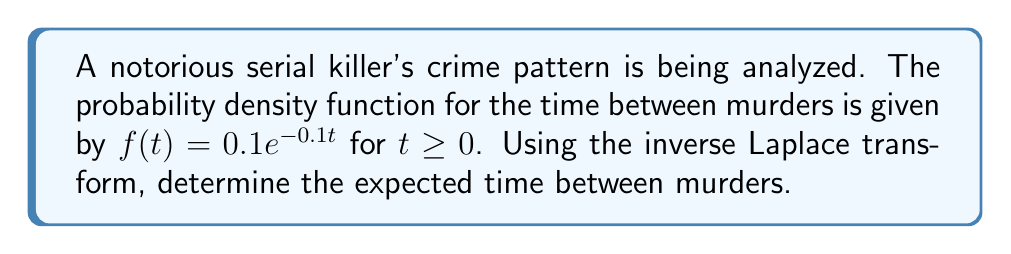Teach me how to tackle this problem. To solve this problem, we'll follow these steps:

1) First, we need to find the Laplace transform of $f(t)$. The Laplace transform of $e^{-at}$ is $\frac{1}{s+a}$, so:

   $$F(s) = \mathcal{L}\{f(t)\} = 0.1 \cdot \frac{1}{s+0.1}$$

2) The expected value of a continuous random variable is given by:

   $$E[T] = \int_0^{\infty} t f(t) dt$$

3) In the s-domain, this is equivalent to:

   $$E[T] = -\frac{dF(s)}{ds}\bigg|_{s=0}$$

4) Let's calculate $\frac{dF(s)}{ds}$:

   $$\frac{dF(s)}{ds} = -0.1 \cdot \frac{1}{(s+0.1)^2}$$

5) Now, we evaluate this at $s=0$:

   $$E[T] = -\frac{dF(s)}{ds}\bigg|_{s=0} = 0.1 \cdot \frac{1}{(0+0.1)^2} = 10$$

Therefore, the expected time between murders is 10 time units (e.g., days, weeks, depending on the context).
Answer: The expected time between murders is 10 time units. 